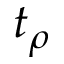<formula> <loc_0><loc_0><loc_500><loc_500>t _ { \rho }</formula> 